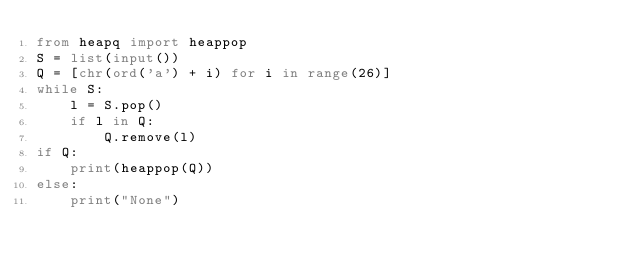Convert code to text. <code><loc_0><loc_0><loc_500><loc_500><_Python_>from heapq import heappop
S = list(input())
Q = [chr(ord('a') + i) for i in range(26)]
while S:
    l = S.pop()
    if l in Q:
        Q.remove(l)
if Q:
    print(heappop(Q))
else:
    print("None")</code> 